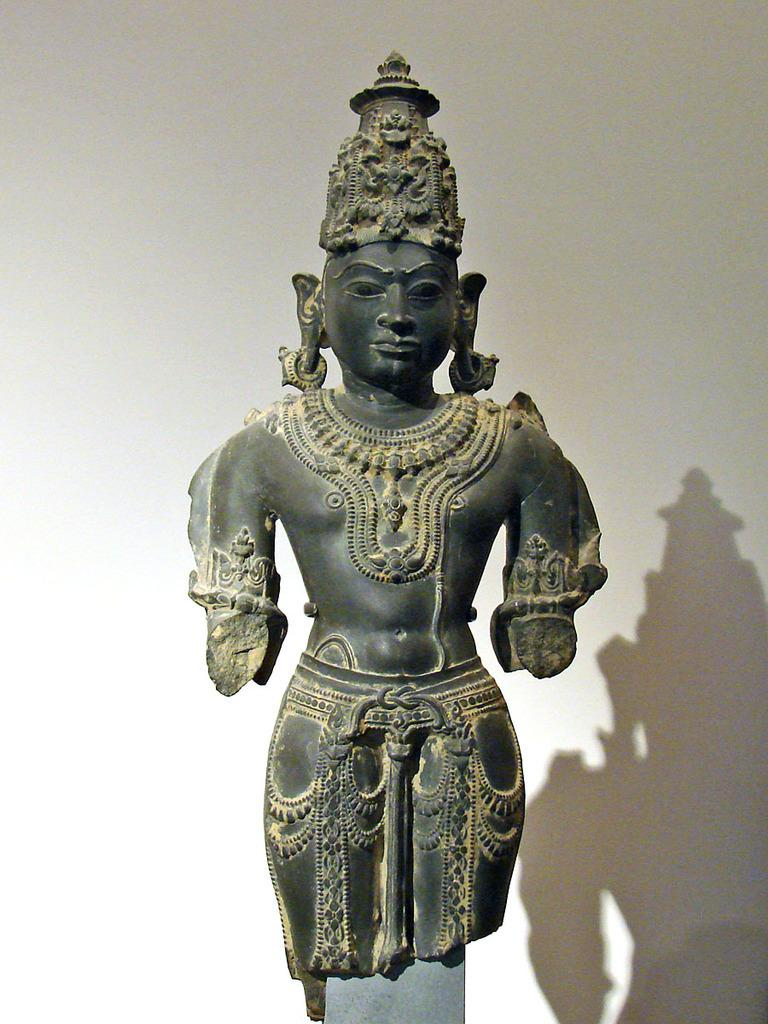What is the main subject in the center of the image? There is a sculpture in the center of the image. What can be seen in the background of the image? There is a wall in the background of the image. What is the position of the lock on the sculpture in the image? There is no lock present on the sculpture in the image. What is the theme of the birthday party in the image? There is no birthday party depicted in the image; it features a sculpture and a wall. 